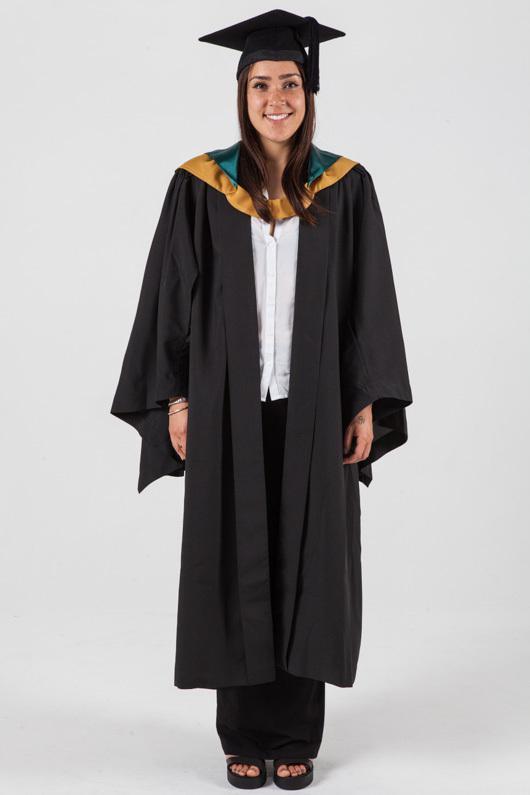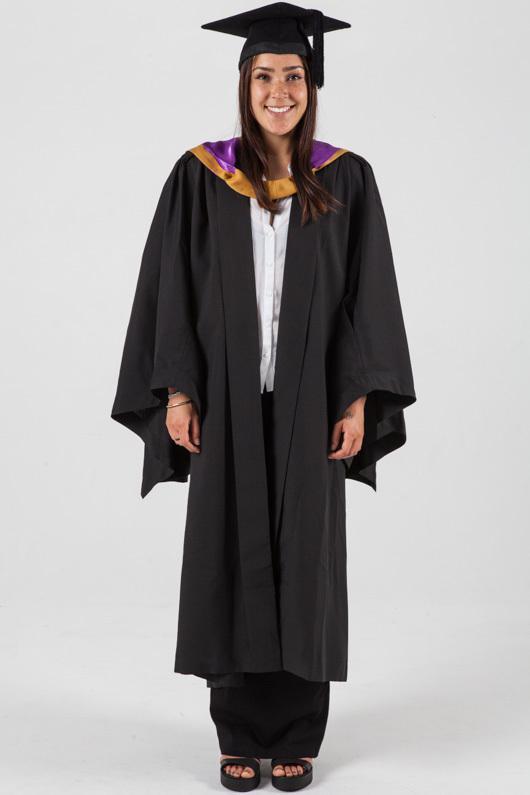The first image is the image on the left, the second image is the image on the right. Considering the images on both sides, is "One of the images features an adult male wearing a black gown and purple color tie." valid? Answer yes or no. No. The first image is the image on the left, the second image is the image on the right. Assess this claim about the two images: "One of the guys is wearing a purple tie.". Correct or not? Answer yes or no. No. 